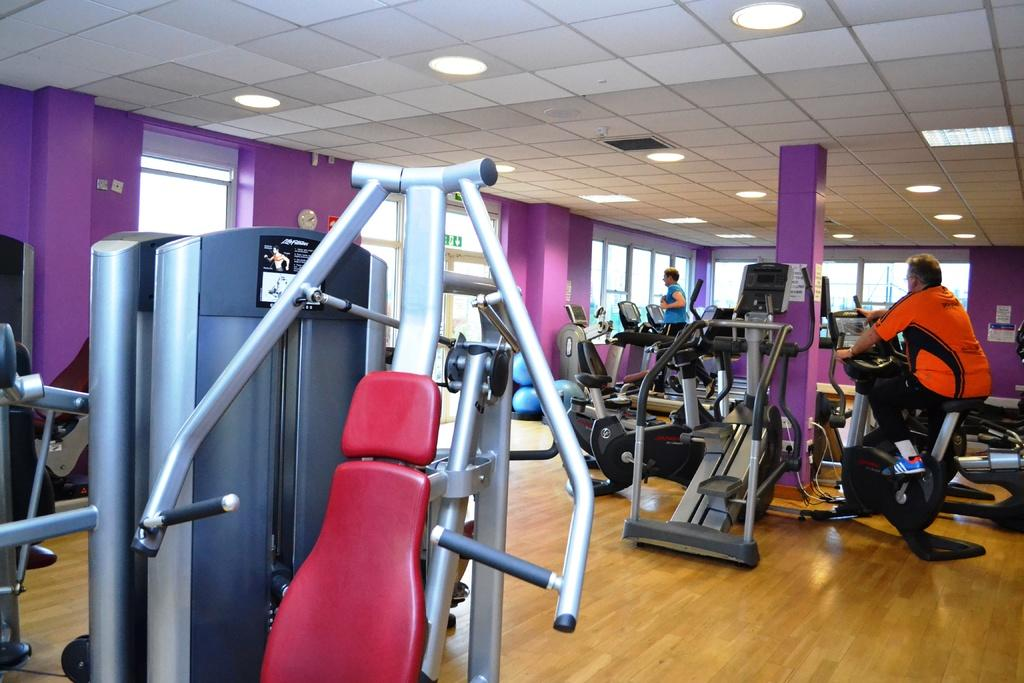What type of equipment can be seen in the image? There are gym equipments in the image. What are the people in the image doing? The people in the image are doing workouts. What is above the gym equipments and people in the image? There is a ceiling visible in the image. What helps to illuminate the gym in the image? There are lights present in the image. What type of channel is being watched by the people working out in the image? There is no indication of a TV or channel in the image; it only shows gym equipment and people working out. 